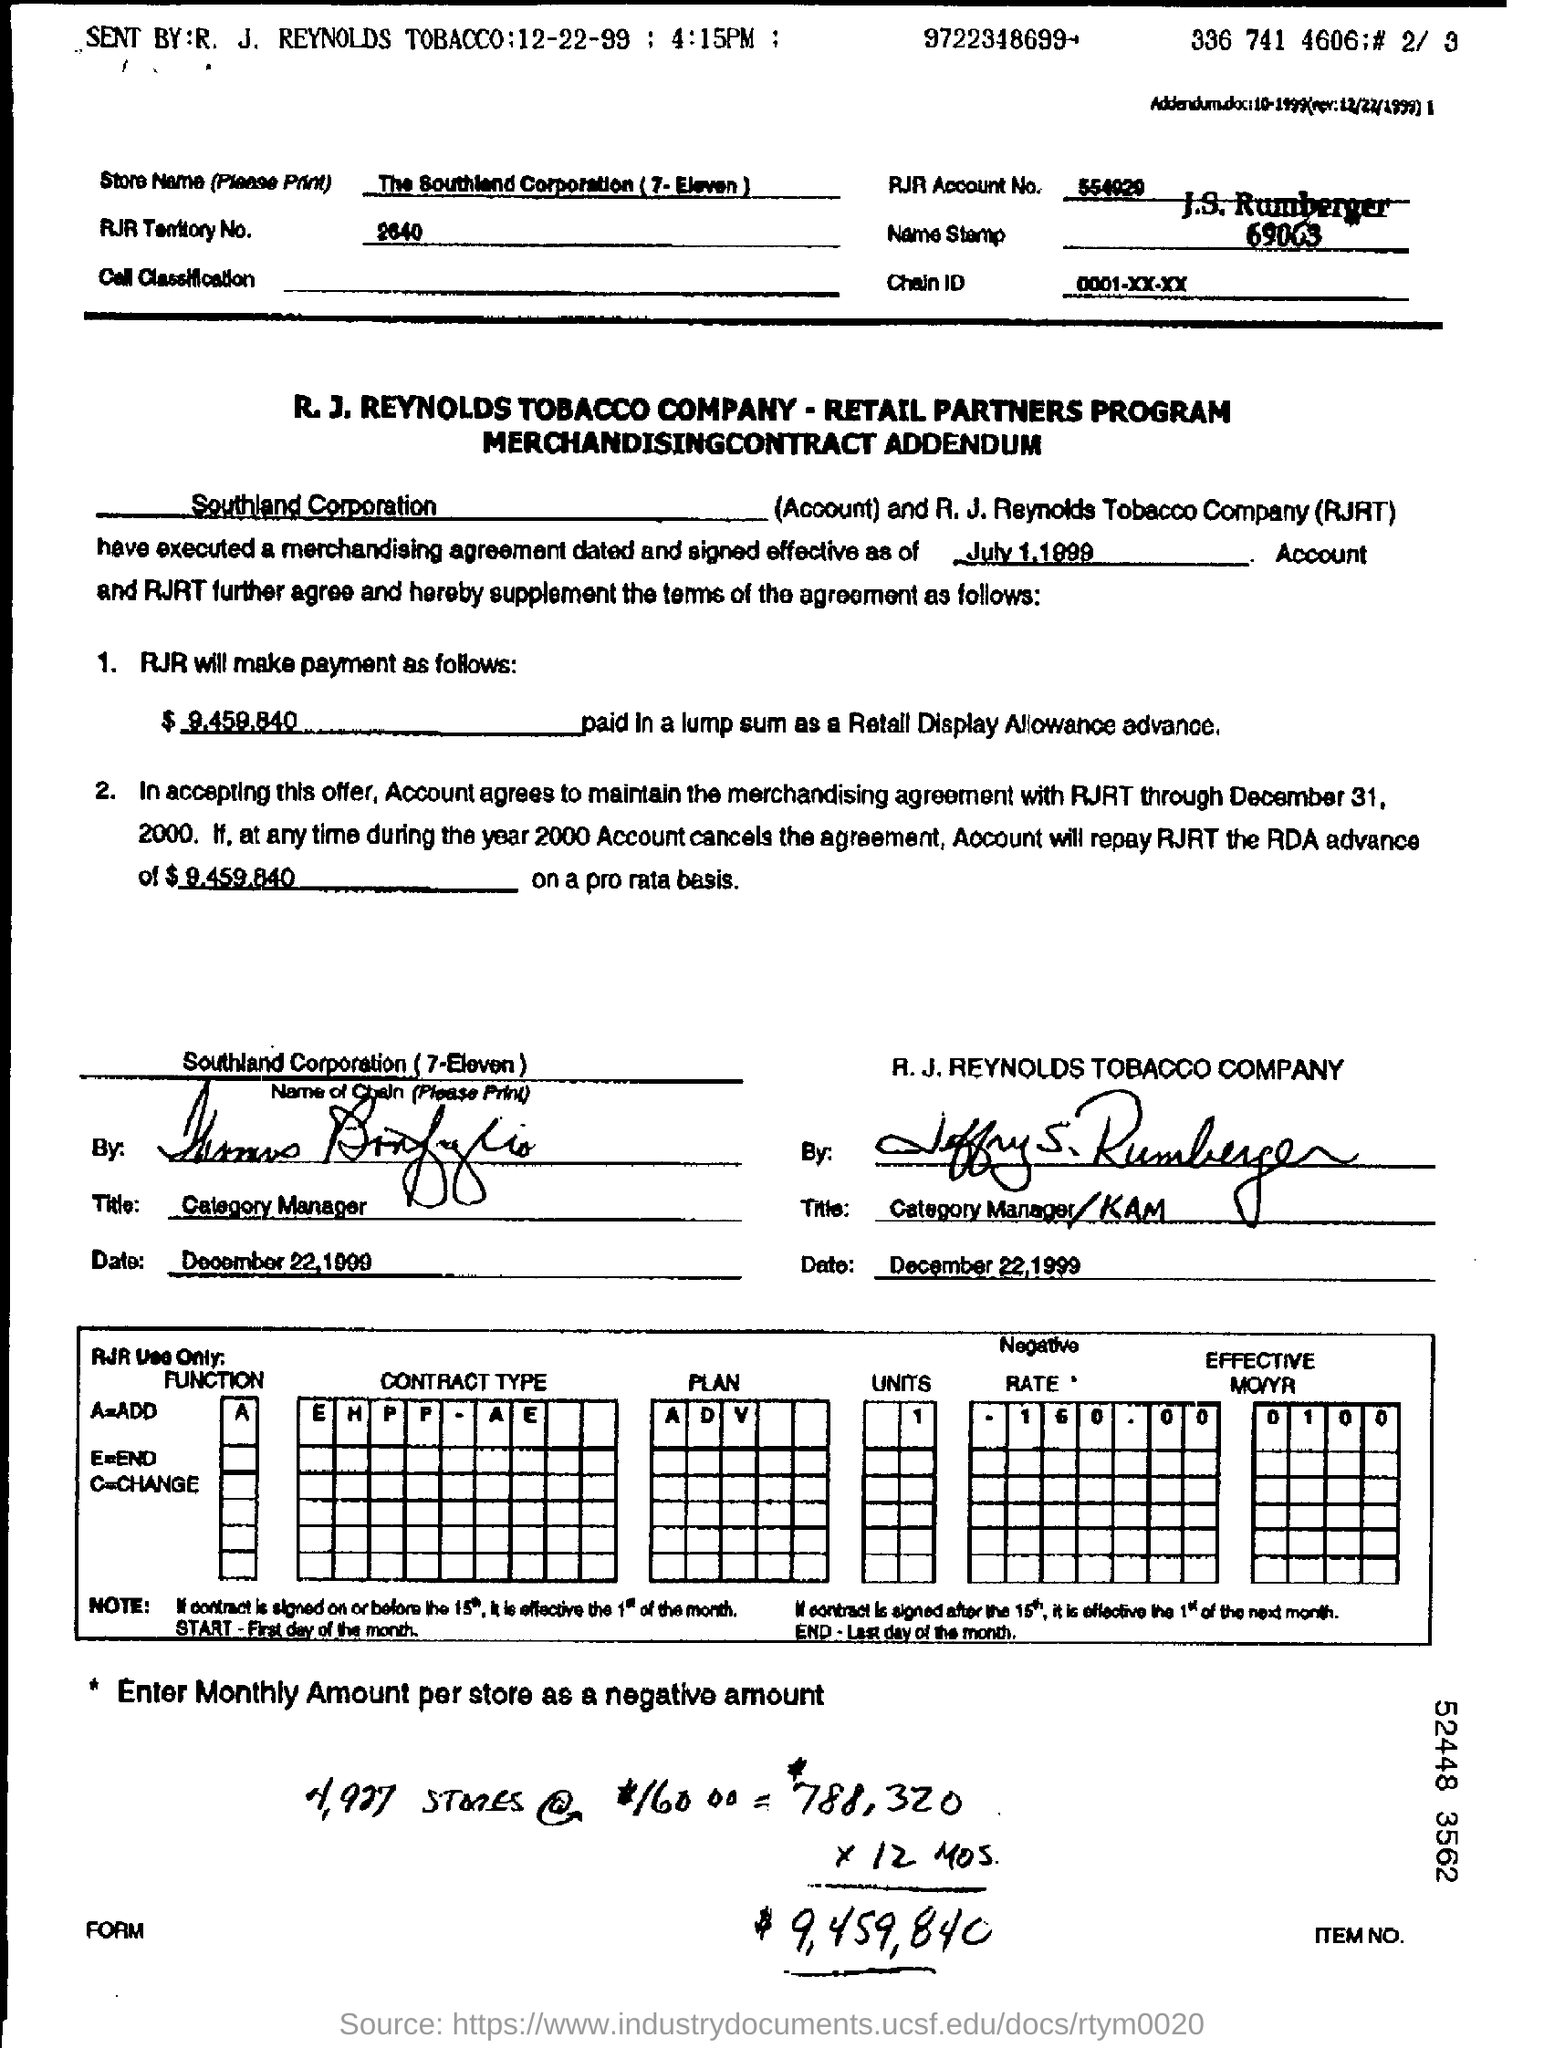Highlight a few significant elements in this photo. The RJR Territory number is 2640. The RJR Account Number is 554020... The merchandising agreement was dated and signed effective as of July 1, 1999. The Southland Corporation, commonly known as 7-Eleven, is a retail company that operates convenience stores. 